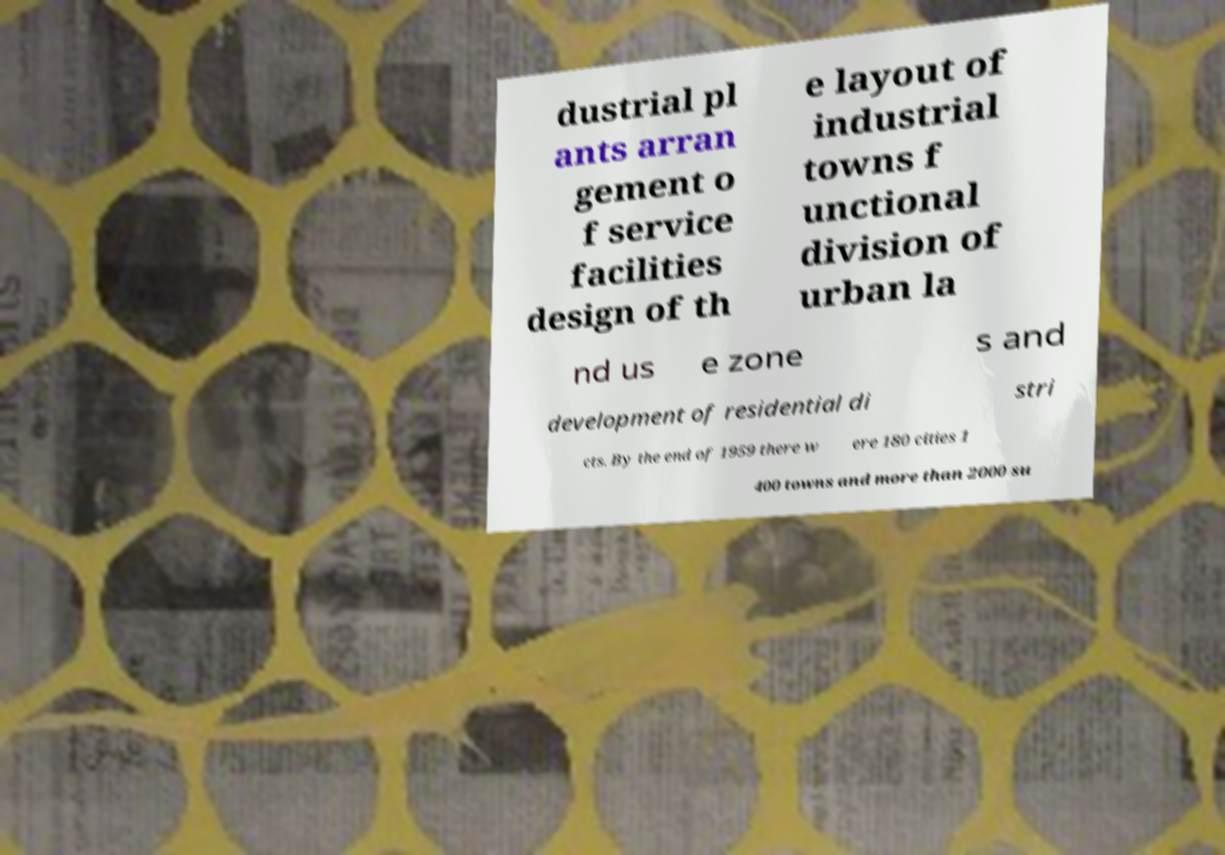What messages or text are displayed in this image? I need them in a readable, typed format. dustrial pl ants arran gement o f service facilities design of th e layout of industrial towns f unctional division of urban la nd us e zone s and development of residential di stri cts. By the end of 1959 there w ere 180 cities 1 400 towns and more than 2000 su 